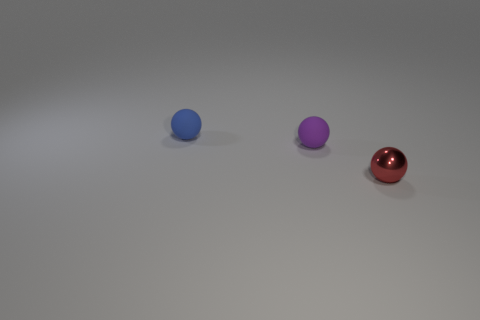Add 3 small red spheres. How many objects exist? 6 Add 2 small cubes. How many small cubes exist? 2 Subtract 0 red blocks. How many objects are left? 3 Subtract all matte objects. Subtract all tiny green metallic things. How many objects are left? 1 Add 2 tiny balls. How many tiny balls are left? 5 